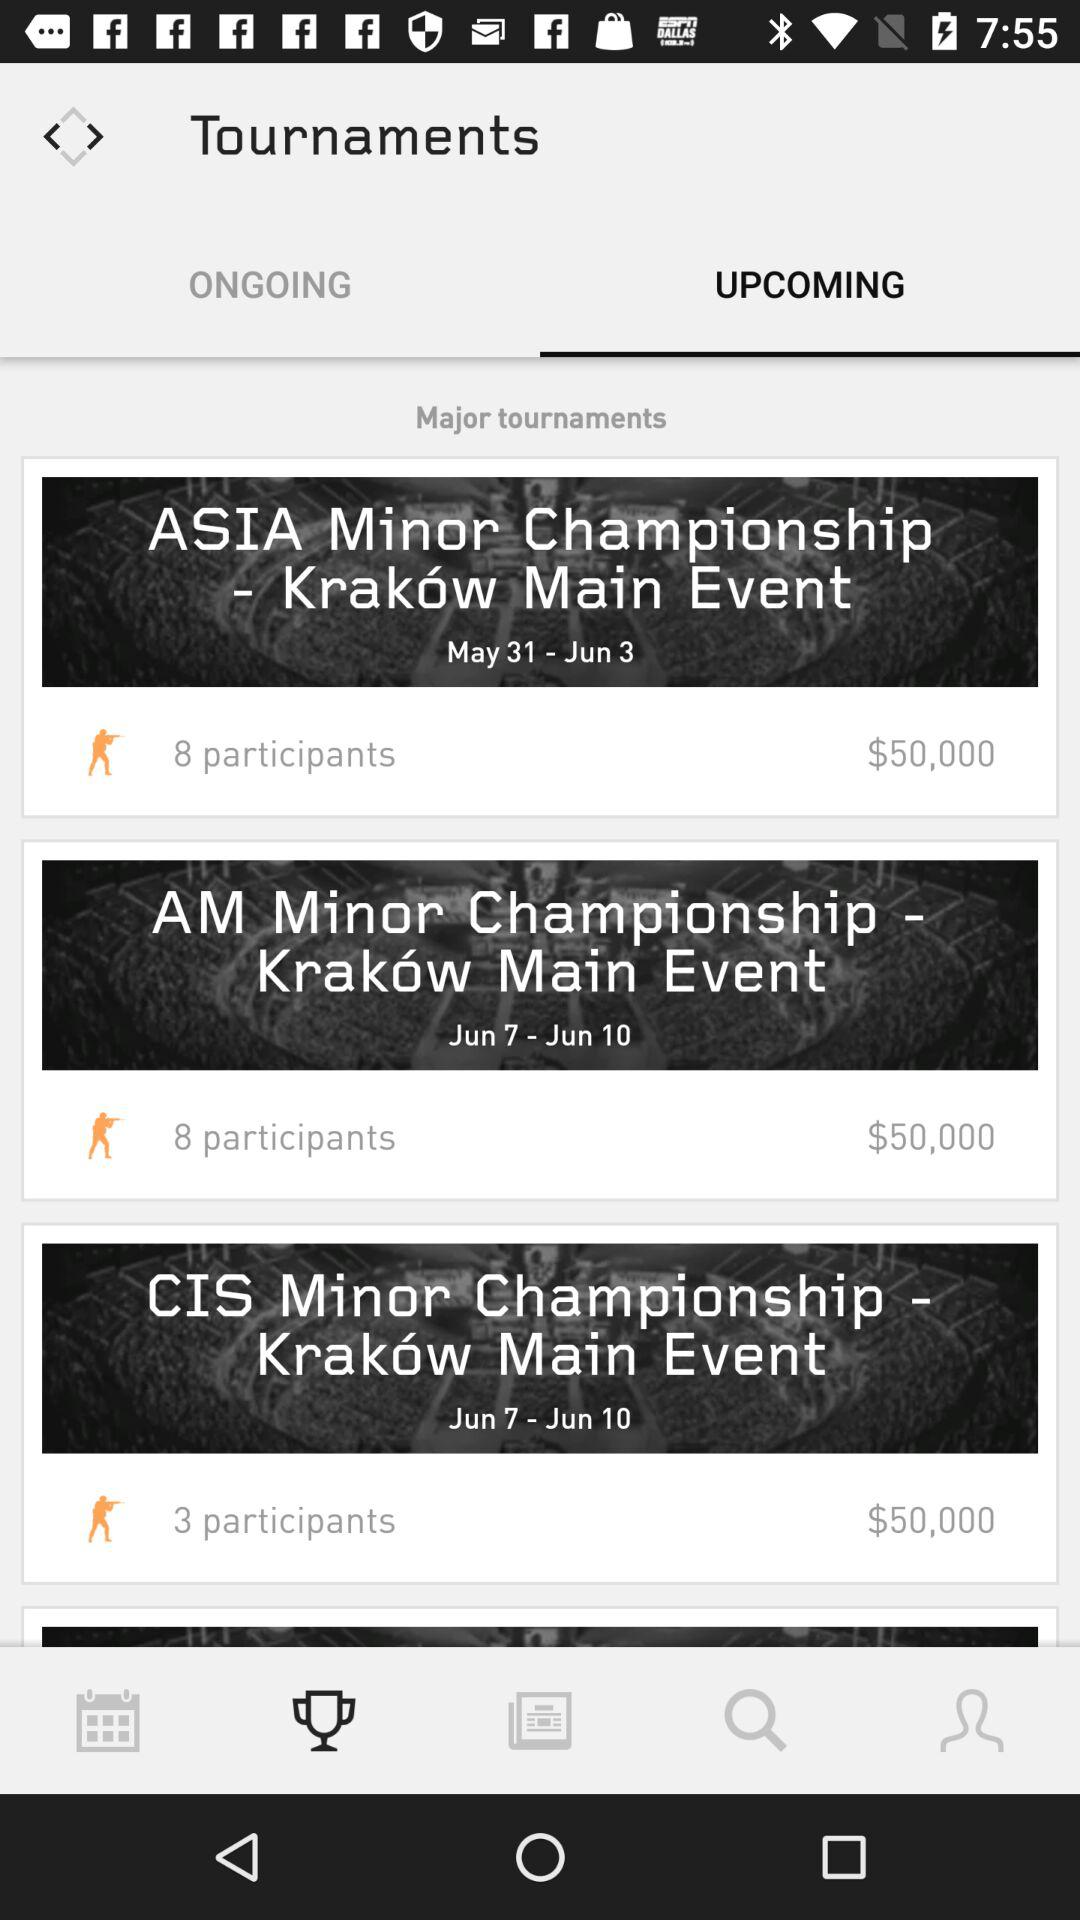What is the prize for the "ASIA Minor Championship"? The prize is $50,000. 